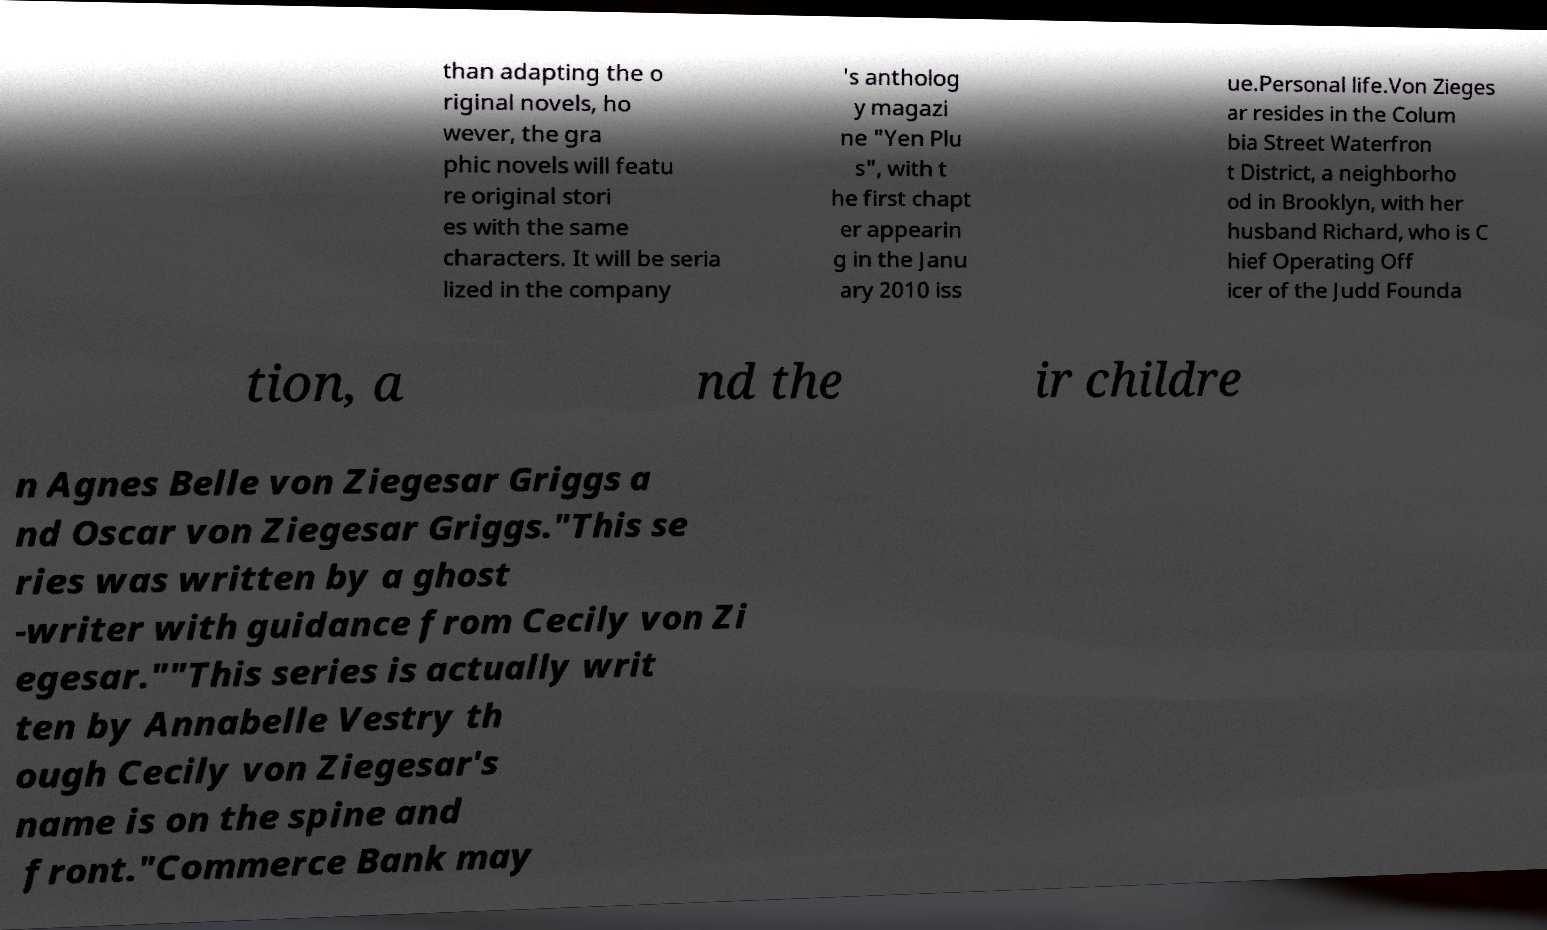Please read and relay the text visible in this image. What does it say? than adapting the o riginal novels, ho wever, the gra phic novels will featu re original stori es with the same characters. It will be seria lized in the company 's antholog y magazi ne "Yen Plu s", with t he first chapt er appearin g in the Janu ary 2010 iss ue.Personal life.Von Zieges ar resides in the Colum bia Street Waterfron t District, a neighborho od in Brooklyn, with her husband Richard, who is C hief Operating Off icer of the Judd Founda tion, a nd the ir childre n Agnes Belle von Ziegesar Griggs a nd Oscar von Ziegesar Griggs."This se ries was written by a ghost -writer with guidance from Cecily von Zi egesar.""This series is actually writ ten by Annabelle Vestry th ough Cecily von Ziegesar's name is on the spine and front."Commerce Bank may 